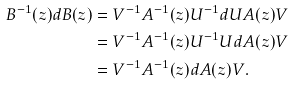<formula> <loc_0><loc_0><loc_500><loc_500>B ^ { - 1 } ( z ) d B ( z ) & = V ^ { - 1 } A ^ { - 1 } ( z ) U ^ { - 1 } d U A ( z ) V \\ & = V ^ { - 1 } A ^ { - 1 } ( z ) U ^ { - 1 } U d A ( z ) V \\ & = V ^ { - 1 } A ^ { - 1 } ( z ) d A ( z ) V .</formula> 